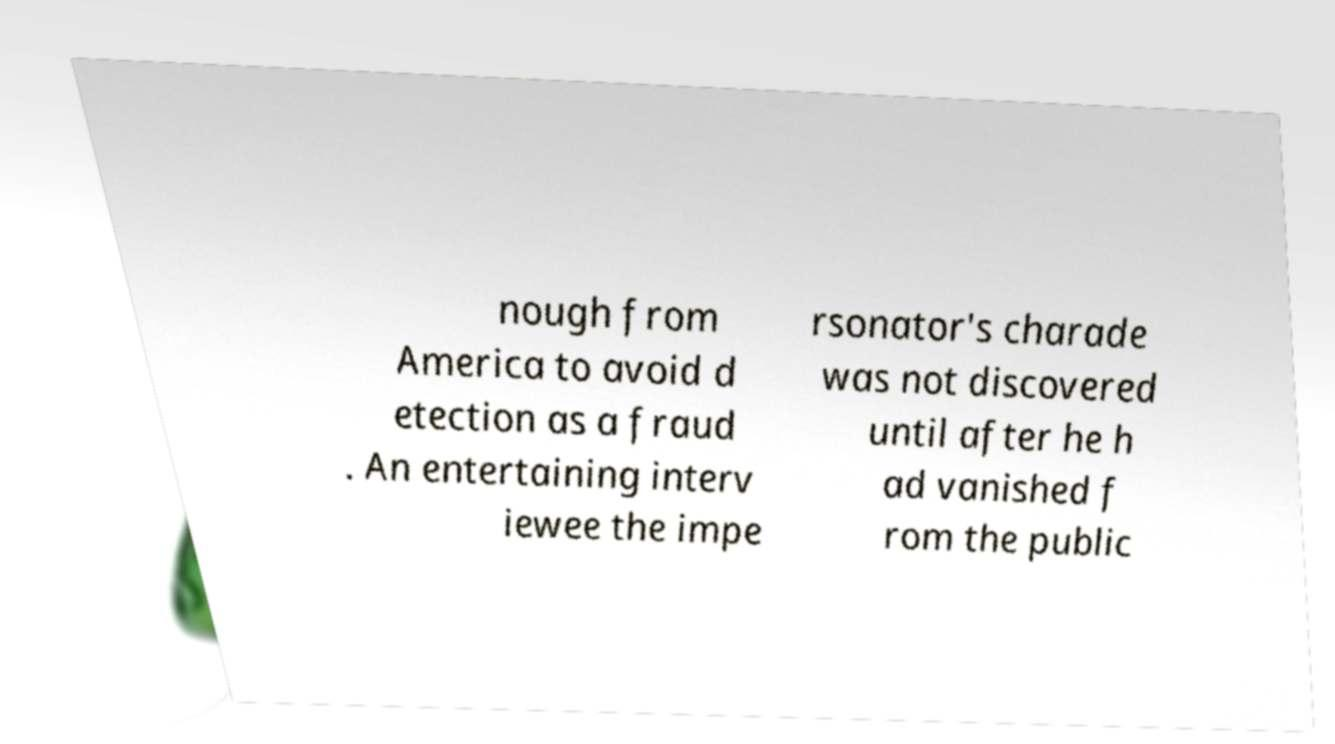Can you read and provide the text displayed in the image?This photo seems to have some interesting text. Can you extract and type it out for me? nough from America to avoid d etection as a fraud . An entertaining interv iewee the impe rsonator's charade was not discovered until after he h ad vanished f rom the public 